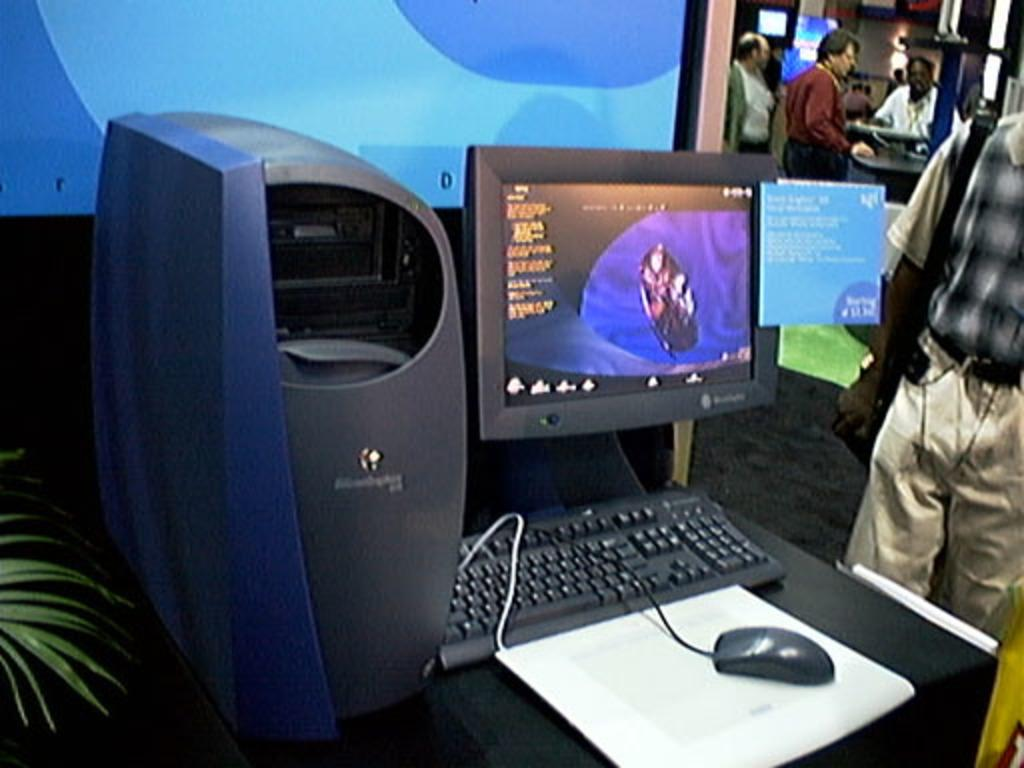What type of furniture is in the image? There is a table in the image. What is on the table? There is a screen, a mouse, and a keyboard on the table. Can you describe the other objects or people in the image? There are other people visible in the image. How does the comb help the heart in the image? There is no comb or heart present in the image. 